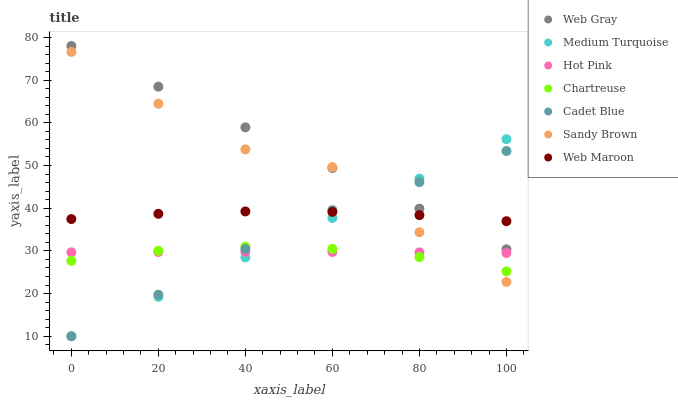Does Chartreuse have the minimum area under the curve?
Answer yes or no. Yes. Does Web Gray have the maximum area under the curve?
Answer yes or no. Yes. Does Hot Pink have the minimum area under the curve?
Answer yes or no. No. Does Hot Pink have the maximum area under the curve?
Answer yes or no. No. Is Medium Turquoise the smoothest?
Answer yes or no. Yes. Is Sandy Brown the roughest?
Answer yes or no. Yes. Is Hot Pink the smoothest?
Answer yes or no. No. Is Hot Pink the roughest?
Answer yes or no. No. Does Cadet Blue have the lowest value?
Answer yes or no. Yes. Does Hot Pink have the lowest value?
Answer yes or no. No. Does Web Gray have the highest value?
Answer yes or no. Yes. Does Web Maroon have the highest value?
Answer yes or no. No. Is Hot Pink less than Web Maroon?
Answer yes or no. Yes. Is Web Maroon greater than Hot Pink?
Answer yes or no. Yes. Does Cadet Blue intersect Web Gray?
Answer yes or no. Yes. Is Cadet Blue less than Web Gray?
Answer yes or no. No. Is Cadet Blue greater than Web Gray?
Answer yes or no. No. Does Hot Pink intersect Web Maroon?
Answer yes or no. No. 